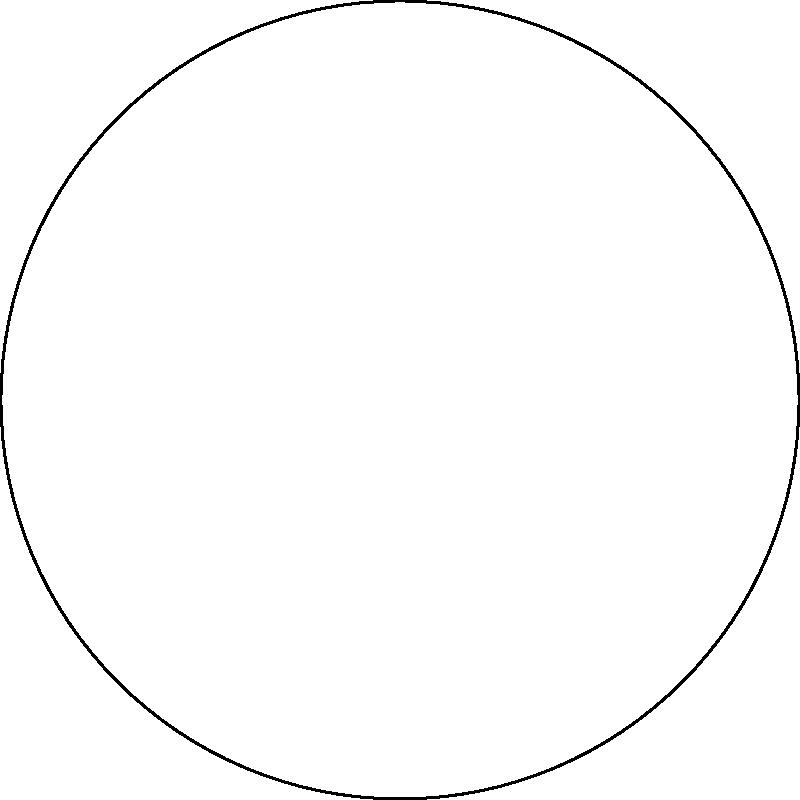In designing an efficient waste management system for a circular economy, you need to optimize the flow of materials through four key stages: collection, sorting, processing, and distribution. If the efficiency of each stage is improved by 10%, what would be the overall efficiency gain of the entire system, assuming the stages are independent and the initial efficiency of each stage was 80%? To solve this problem, we need to follow these steps:

1. Calculate the new efficiency for each stage:
   Initial efficiency = 80%
   Improvement = 10% of 80% = 0.1 * 0.8 = 0.08
   New efficiency = 80% + 8% = 88% = 0.88

2. Calculate the overall efficiency of the system:
   In a series of independent processes, the overall efficiency is the product of individual efficiencies.

   Initial overall efficiency:
   $$E_i = 0.8 * 0.8 * 0.8 * 0.8 = 0.8^4 = 0.4096 = 40.96\%$$

   New overall efficiency:
   $$E_n = 0.88 * 0.88 * 0.88 * 0.88 = 0.88^4 = 0.5987 = 59.87\%$$

3. Calculate the efficiency gain:
   $$\text{Efficiency gain} = E_n - E_i = 59.87\% - 40.96\% = 18.91\%$$

4. Express the efficiency gain as a percentage increase:
   $$\text{Percentage increase} = \frac{E_n - E_i}{E_i} * 100\% = \frac{0.5987 - 0.4096}{0.4096} * 100\% = 46.17\%$$

Therefore, the overall efficiency gain of the entire system would be approximately 46.17%.
Answer: 46.17% 